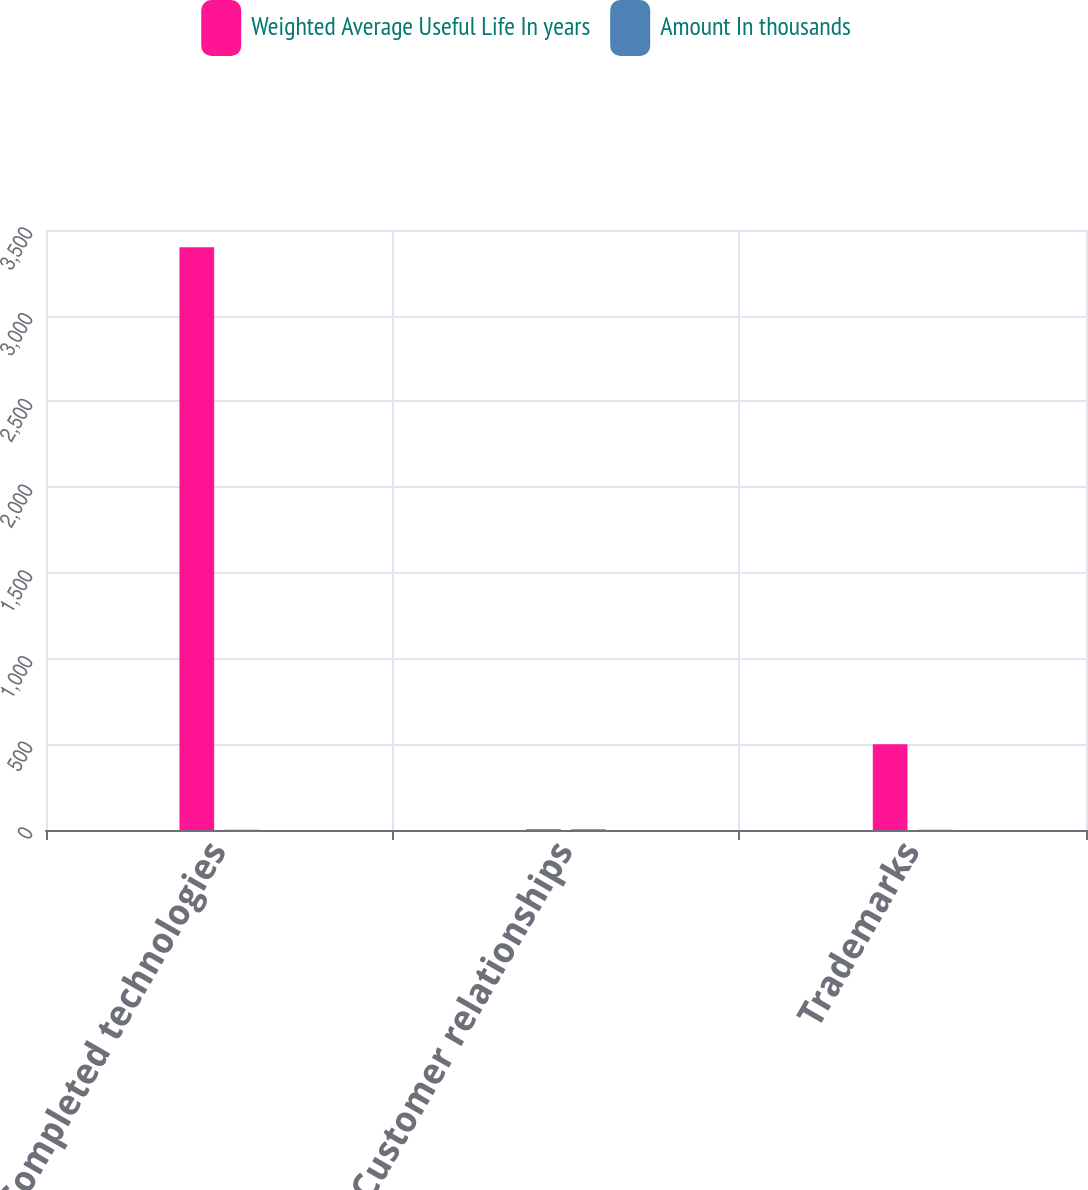Convert chart to OTSL. <chart><loc_0><loc_0><loc_500><loc_500><stacked_bar_chart><ecel><fcel>Completed technologies<fcel>Customer relationships<fcel>Trademarks<nl><fcel>Weighted Average Useful Life In years<fcel>3400<fcel>4.5<fcel>500<nl><fcel>Amount In thousands<fcel>1.7<fcel>4.5<fcel>2.1<nl></chart> 